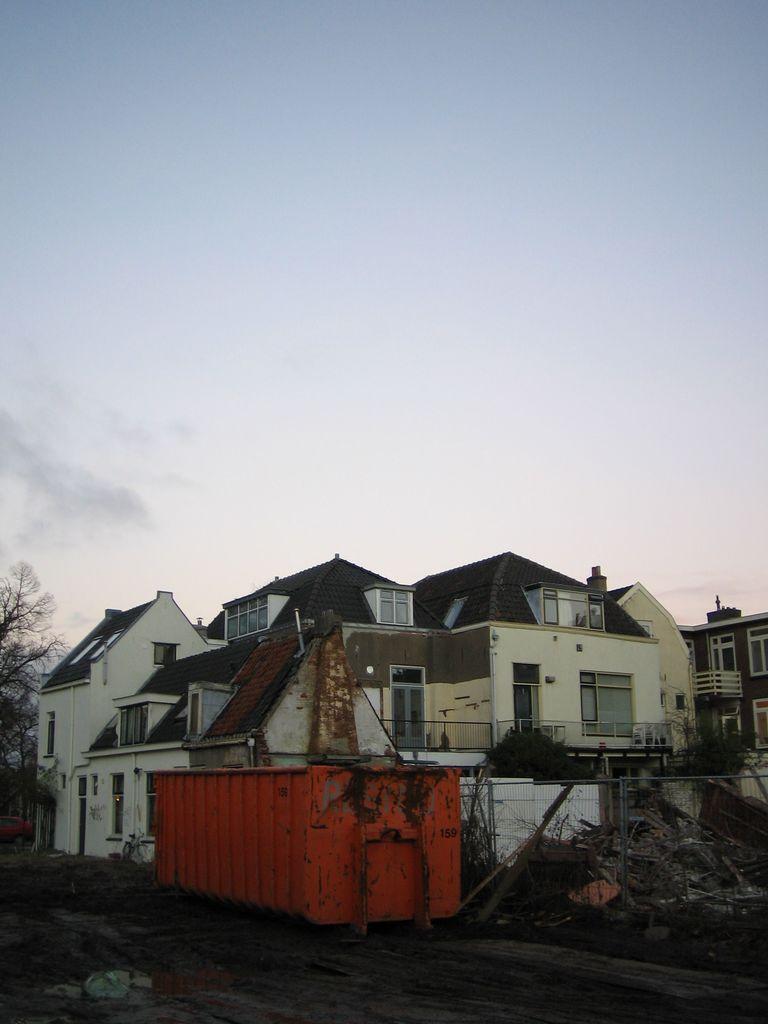Please provide a concise description of this image. There are buildings at the bottom of this image and there are some trees on the left side of this image and right side of this image as well. The sky is at the top of this image. 